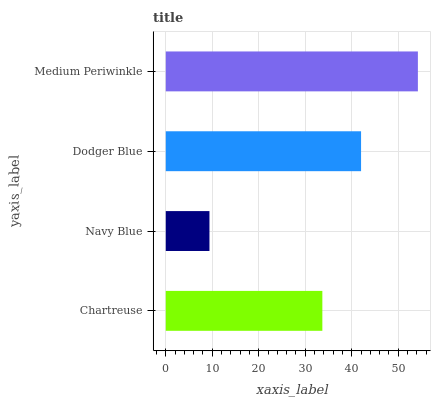Is Navy Blue the minimum?
Answer yes or no. Yes. Is Medium Periwinkle the maximum?
Answer yes or no. Yes. Is Dodger Blue the minimum?
Answer yes or no. No. Is Dodger Blue the maximum?
Answer yes or no. No. Is Dodger Blue greater than Navy Blue?
Answer yes or no. Yes. Is Navy Blue less than Dodger Blue?
Answer yes or no. Yes. Is Navy Blue greater than Dodger Blue?
Answer yes or no. No. Is Dodger Blue less than Navy Blue?
Answer yes or no. No. Is Dodger Blue the high median?
Answer yes or no. Yes. Is Chartreuse the low median?
Answer yes or no. Yes. Is Chartreuse the high median?
Answer yes or no. No. Is Medium Periwinkle the low median?
Answer yes or no. No. 